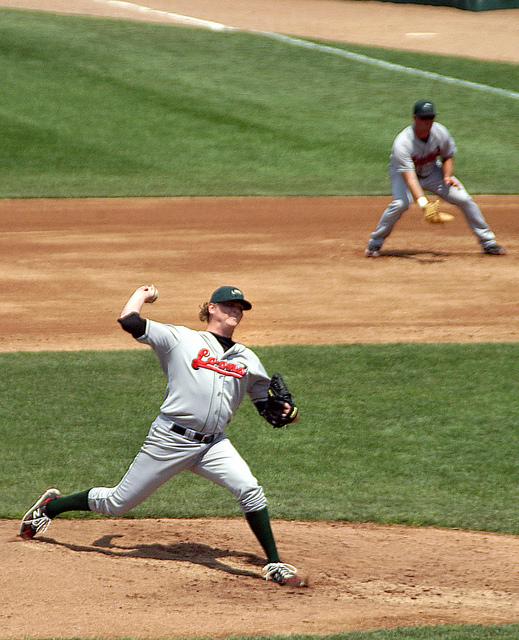How many field positions are visible in this picture?
Answer briefly. 2. Where are the players playing?
Keep it brief. Baseball. Does this look like a game or a training session?
Keep it brief. Game. What team is this?
Keep it brief. Don't know. Is there an umpire?
Be succinct. No. 